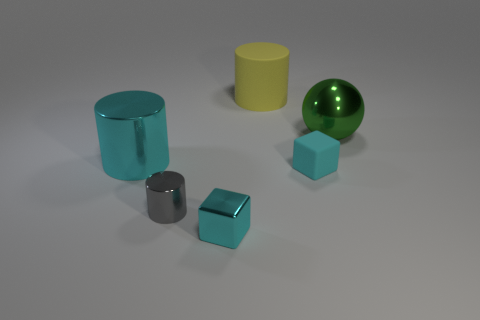There is a large thing that is made of the same material as the large sphere; what is its shape?
Offer a terse response. Cylinder. There is a metal cylinder that is in front of the cyan metal cylinder; are there any big metallic cylinders that are to the right of it?
Provide a short and direct response. No. How big is the yellow rubber cylinder?
Keep it short and to the point. Large. What number of things are either small purple shiny cylinders or rubber cylinders?
Offer a terse response. 1. Is the tiny cyan thing behind the tiny shiny block made of the same material as the cylinder that is behind the cyan cylinder?
Offer a very short reply. Yes. What color is the big ball that is made of the same material as the small gray thing?
Offer a very short reply. Green. How many matte blocks are the same size as the cyan matte thing?
Keep it short and to the point. 0. What number of other things are there of the same color as the tiny shiny cube?
Your response must be concise. 2. There is a cyan metallic object in front of the big cyan thing; is it the same shape as the rubber thing in front of the large green metallic ball?
Give a very brief answer. Yes. The metal object that is the same size as the gray metal cylinder is what shape?
Your answer should be very brief. Cube. 